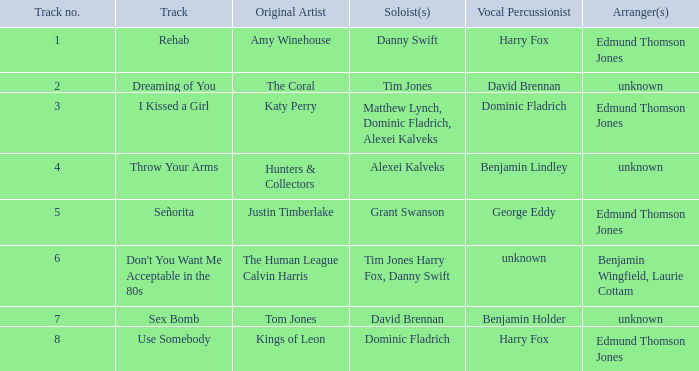Who was responsible for arranging "i kissed a girl"? Edmund Thomson Jones. 